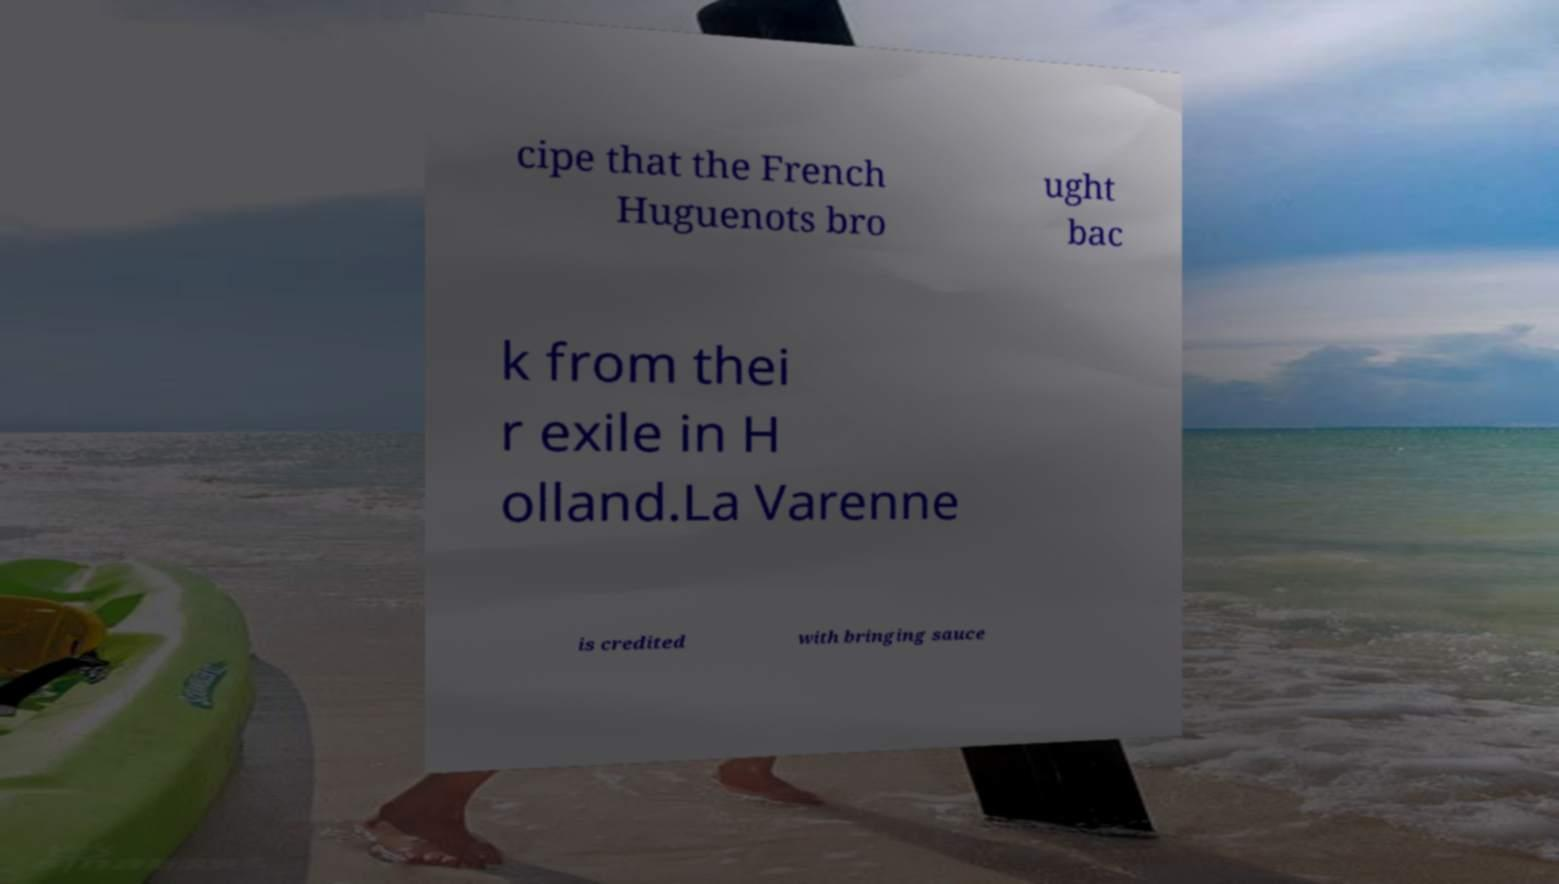Could you assist in decoding the text presented in this image and type it out clearly? cipe that the French Huguenots bro ught bac k from thei r exile in H olland.La Varenne is credited with bringing sauce 